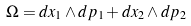Convert formula to latex. <formula><loc_0><loc_0><loc_500><loc_500>\Omega = d x _ { 1 } \wedge d p _ { 1 } + d x _ { 2 } \wedge d p _ { 2 }</formula> 